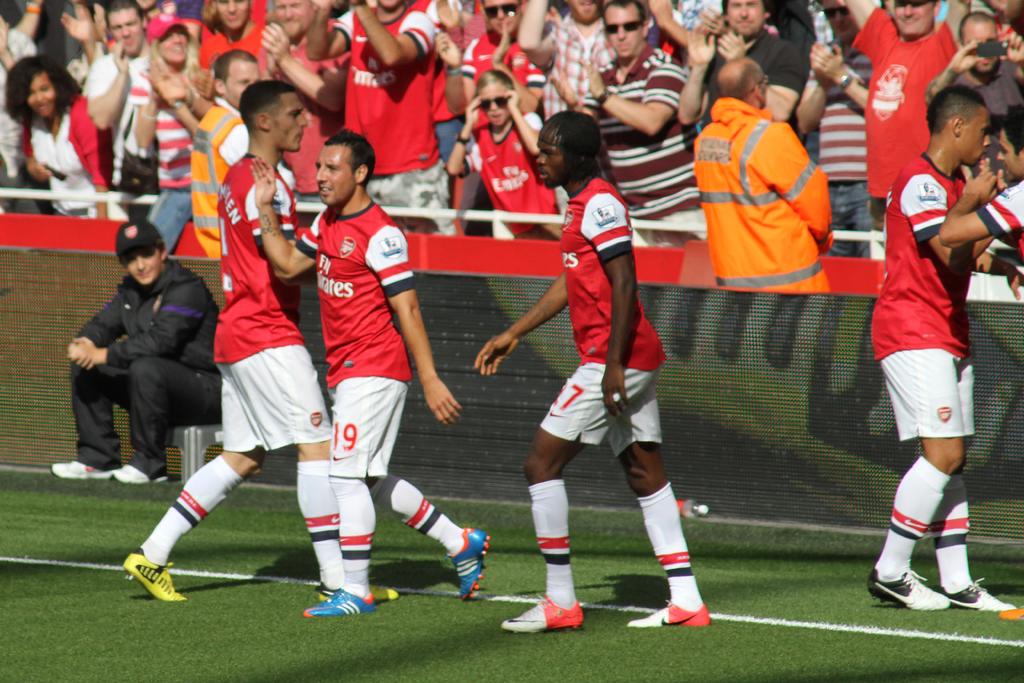What number is on the shorter player?
Provide a succinct answer. 19. 